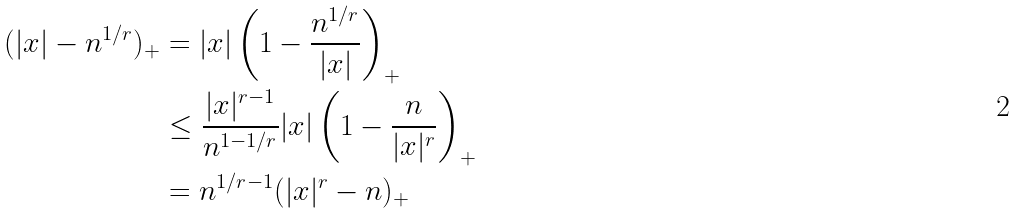<formula> <loc_0><loc_0><loc_500><loc_500>( | x | - n ^ { 1 / r } ) _ { + } & = | x | \left ( 1 - \frac { n ^ { 1 / r } } { | x | } \right ) _ { + } \\ & \leq \frac { | x | ^ { r - 1 } } { n ^ { 1 - 1 / r } } | x | \left ( 1 - \frac { n } { | x | ^ { r } } \right ) _ { + } \\ & = n ^ { 1 / r - 1 } ( | x | ^ { r } - n ) _ { + }</formula> 